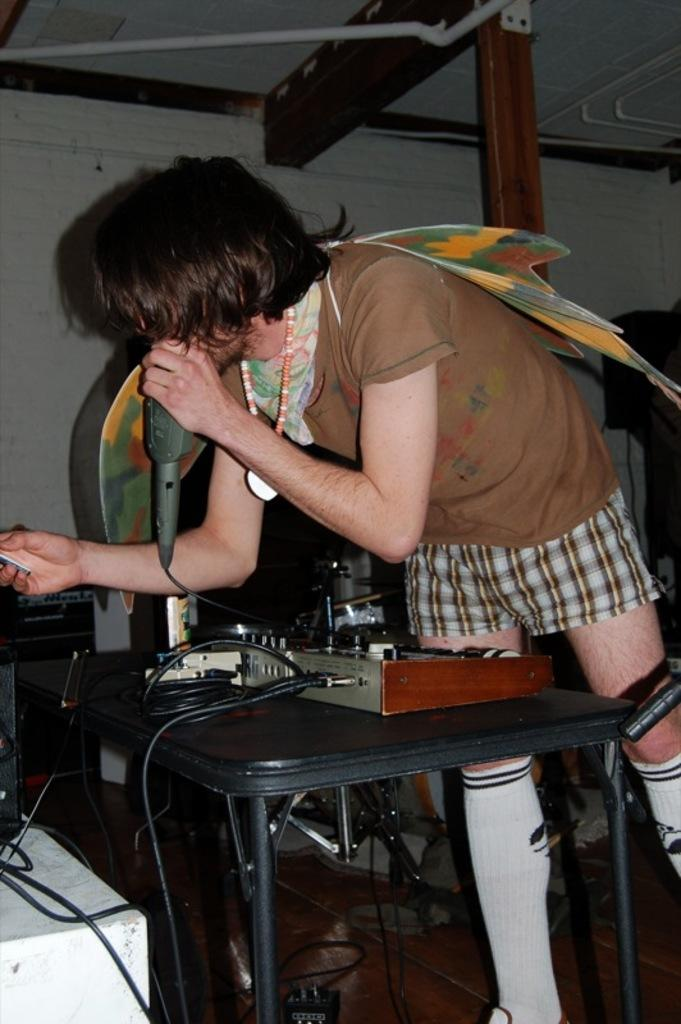What is the main subject of the image? There is a man in the image. What is the man wearing on his upper body? The man is wearing a shirt and a t-shirt. What is the man holding in the image? The man is holding a mug. What can be said about the man's hair color? The man has black hair. What type of belief system is the man following in the image? There is no information about the man's belief system in the image. How many balls can be seen in the image? There are no balls present in the image. 